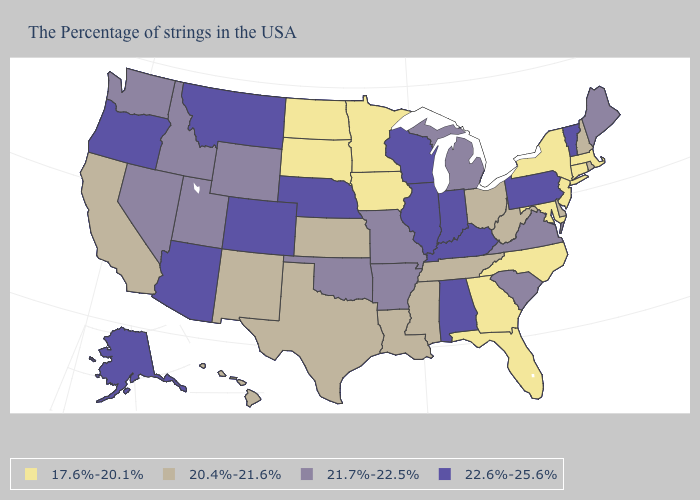What is the lowest value in the South?
Keep it brief. 17.6%-20.1%. Does the map have missing data?
Write a very short answer. No. What is the value of New Hampshire?
Short answer required. 20.4%-21.6%. Does Ohio have a lower value than Michigan?
Write a very short answer. Yes. Among the states that border Indiana , which have the lowest value?
Give a very brief answer. Ohio. Among the states that border Minnesota , does South Dakota have the lowest value?
Answer briefly. Yes. Name the states that have a value in the range 17.6%-20.1%?
Write a very short answer. Massachusetts, Connecticut, New York, New Jersey, Maryland, North Carolina, Florida, Georgia, Minnesota, Iowa, South Dakota, North Dakota. Name the states that have a value in the range 20.4%-21.6%?
Keep it brief. Rhode Island, New Hampshire, Delaware, West Virginia, Ohio, Tennessee, Mississippi, Louisiana, Kansas, Texas, New Mexico, California, Hawaii. What is the highest value in the Northeast ?
Keep it brief. 22.6%-25.6%. Which states have the lowest value in the Northeast?
Concise answer only. Massachusetts, Connecticut, New York, New Jersey. Among the states that border Pennsylvania , does West Virginia have the lowest value?
Be succinct. No. What is the value of Pennsylvania?
Quick response, please. 22.6%-25.6%. Does Minnesota have the highest value in the MidWest?
Give a very brief answer. No. Does Utah have the same value as Michigan?
Be succinct. Yes. 